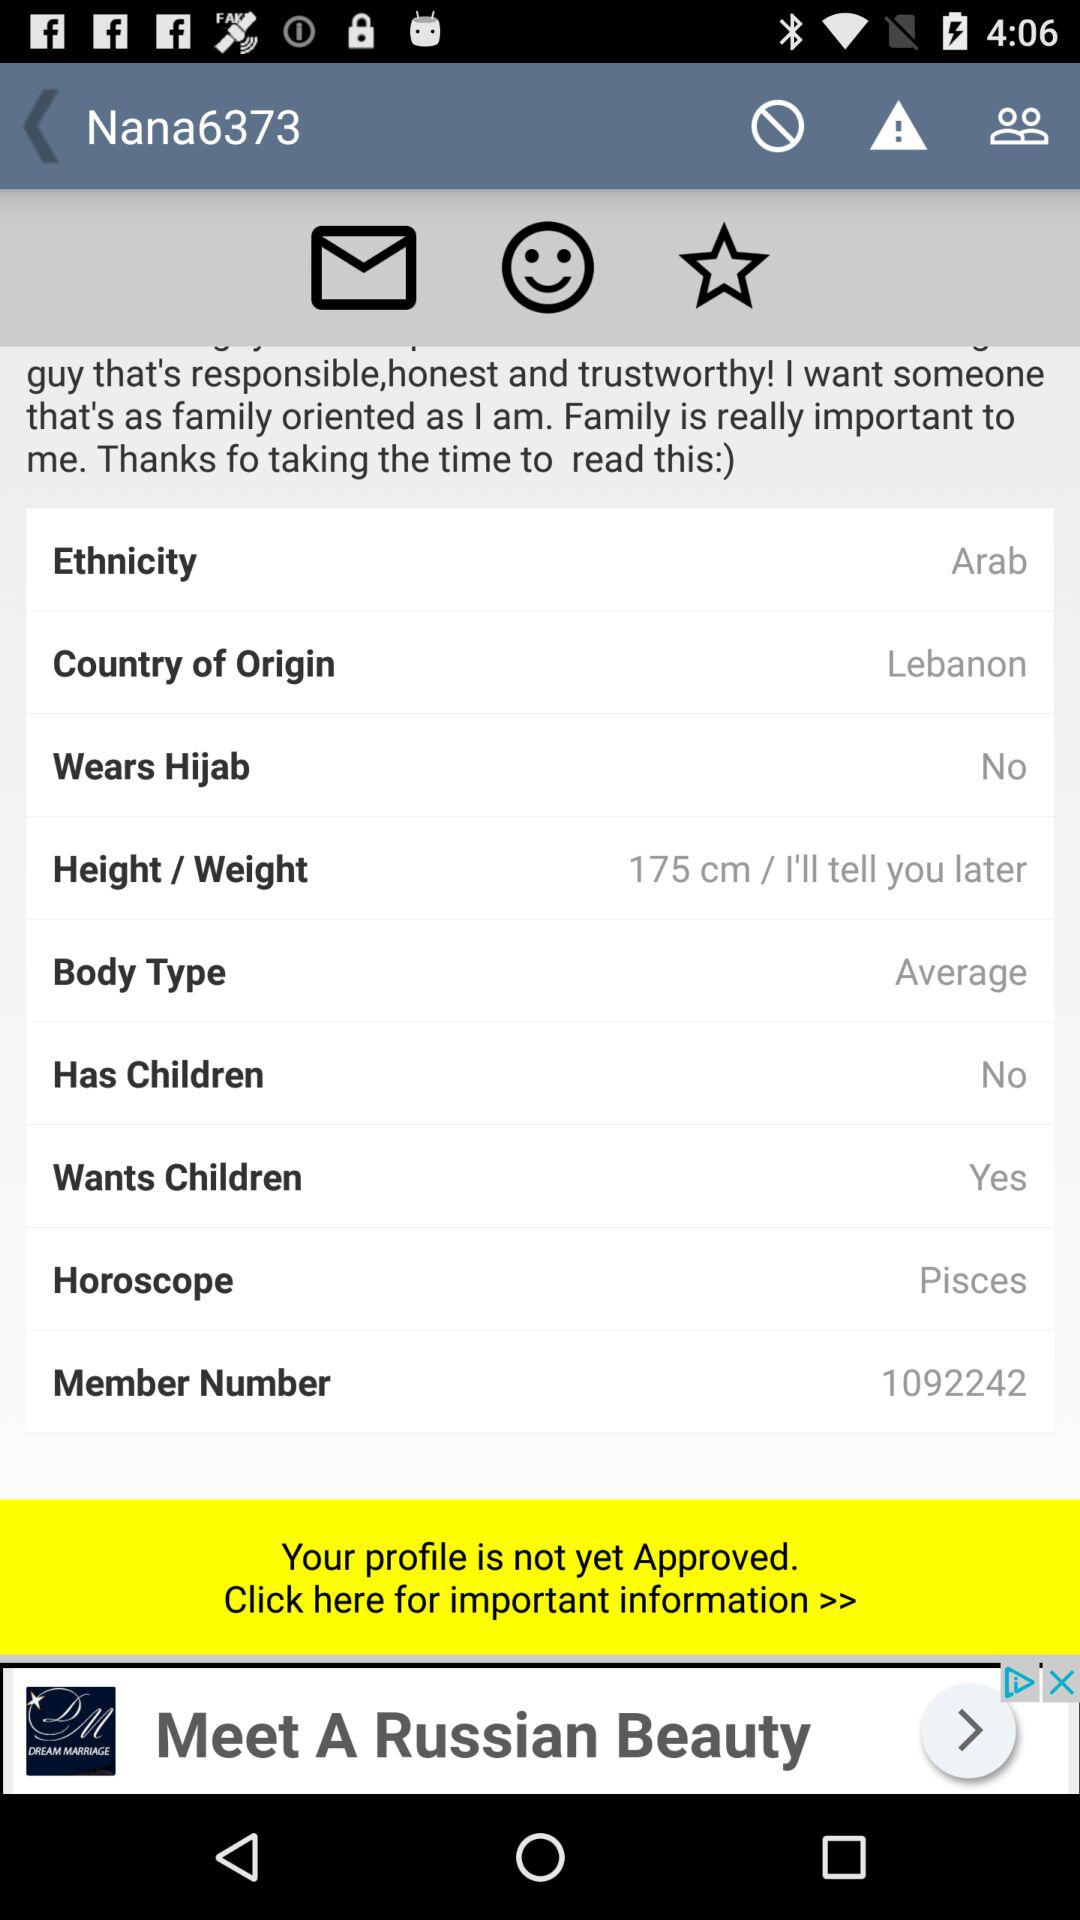What is the status of the user's profile? The user's profile is not yet approved. 